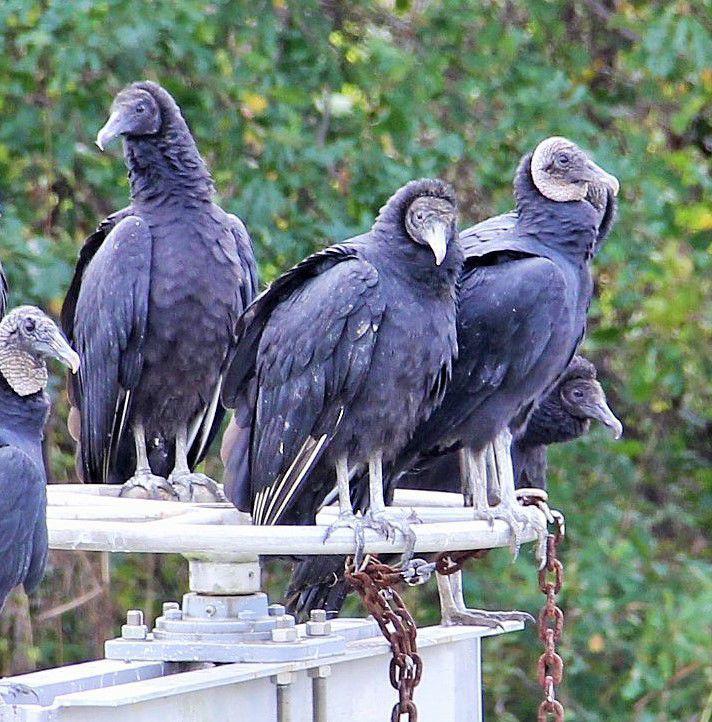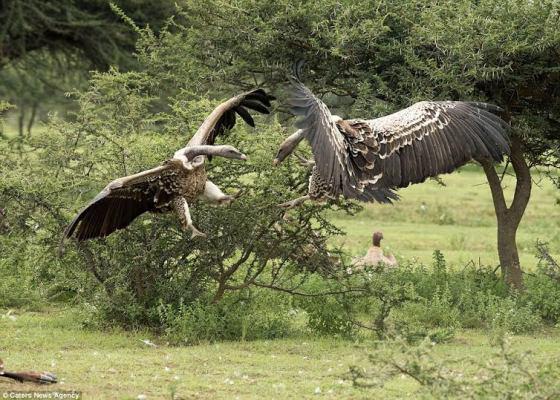The first image is the image on the left, the second image is the image on the right. For the images shown, is this caption "An image shows two vultures in the foreground, at least one with its wings outspread." true? Answer yes or no. Yes. The first image is the image on the left, the second image is the image on the right. For the images displayed, is the sentence "In at least one image there is a total of five vultures." factually correct? Answer yes or no. Yes. 